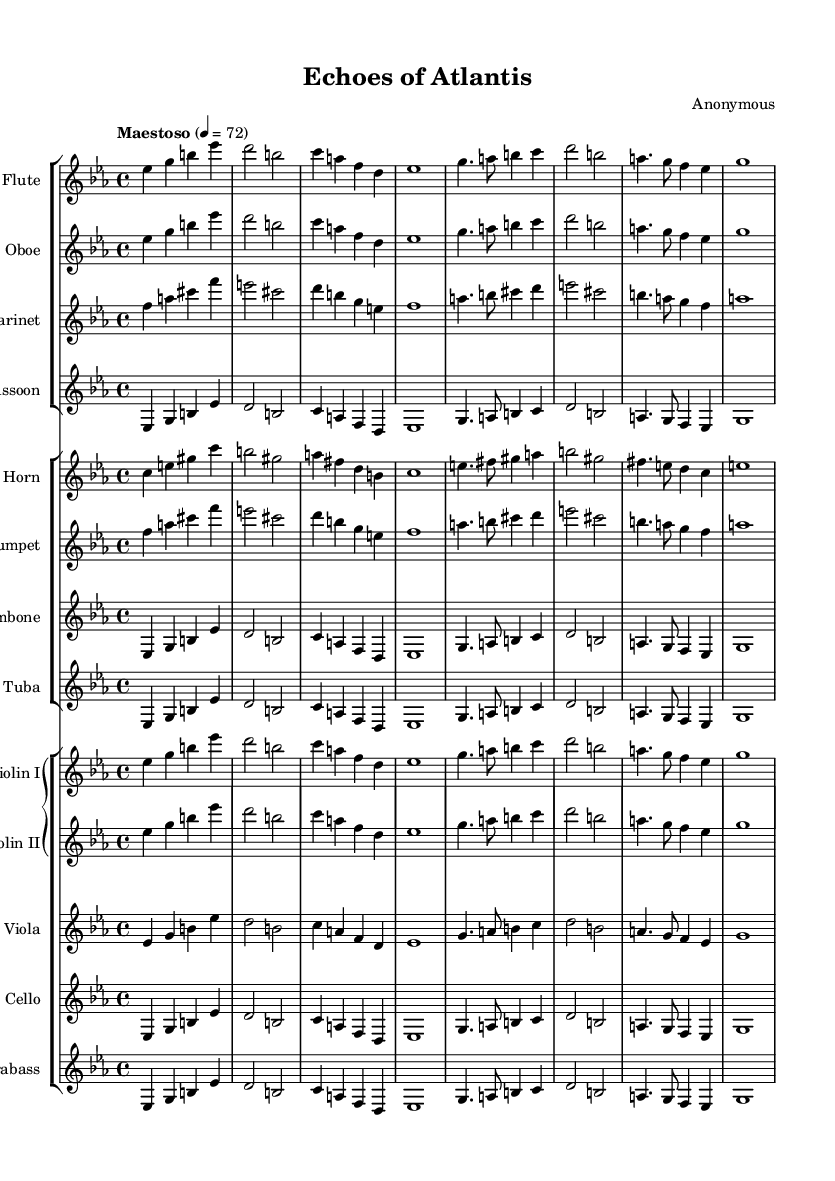What is the key signature of this music? The key signature indicates that the music is in E-flat major, which has three flats (B-flat, E-flat, and A-flat).
Answer: E-flat major What is the time signature of this piece? The time signature shown in the sheet music is 4/4, which indicates four beats per measure and a quarter note receives one beat.
Answer: 4/4 What is the tempo marking of the score? The tempo marking states "Maestoso," which means majestic and is set at a speed of 72 beats per minute, indicating a slow and grand pace.
Answer: Maestoso How many different instrument groups are present in the score? The score contains three groups of instruments: woodwinds, brass, and strings. This grouping is evident in the organization of the staves.
Answer: Three Identify the first note of the Flute part. The Flute part begins with the note E-flat, which is indicated at the beginning of the staff for that instrument.
Answer: E-flat What is the key characteristic of Romantic opera overtures in this piece? The piece utilizes lush orchestration and evocative melodies that reflect the grandeur of lost civilizations, typical of Romantic opera overtures.
Answer: Lush orchestration What is the highest instrument in the orchestration? In this orchestration, the highest instrument present is the Flute, which typically plays in the higher register compared to other instruments in the score.
Answer: Flute 